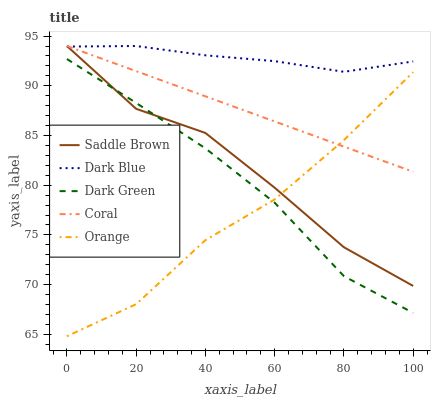Does Orange have the minimum area under the curve?
Answer yes or no. Yes. Does Dark Blue have the maximum area under the curve?
Answer yes or no. Yes. Does Coral have the minimum area under the curve?
Answer yes or no. No. Does Coral have the maximum area under the curve?
Answer yes or no. No. Is Coral the smoothest?
Answer yes or no. Yes. Is Saddle Brown the roughest?
Answer yes or no. Yes. Is Dark Blue the smoothest?
Answer yes or no. No. Is Dark Blue the roughest?
Answer yes or no. No. Does Orange have the lowest value?
Answer yes or no. Yes. Does Coral have the lowest value?
Answer yes or no. No. Does Saddle Brown have the highest value?
Answer yes or no. Yes. Does Dark Green have the highest value?
Answer yes or no. No. Is Orange less than Dark Blue?
Answer yes or no. Yes. Is Dark Blue greater than Dark Green?
Answer yes or no. Yes. Does Saddle Brown intersect Dark Green?
Answer yes or no. Yes. Is Saddle Brown less than Dark Green?
Answer yes or no. No. Is Saddle Brown greater than Dark Green?
Answer yes or no. No. Does Orange intersect Dark Blue?
Answer yes or no. No. 